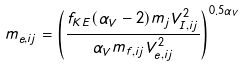<formula> <loc_0><loc_0><loc_500><loc_500>m _ { e , i j } = \left ( \frac { f _ { K E } ( \alpha _ { V } - 2 ) m _ { j } V _ { I , i j } ^ { 2 } } { \alpha _ { V } m _ { f , i j } V _ { e , i j } ^ { 2 } } \right ) ^ { 0 . 5 \alpha _ { V } }</formula> 